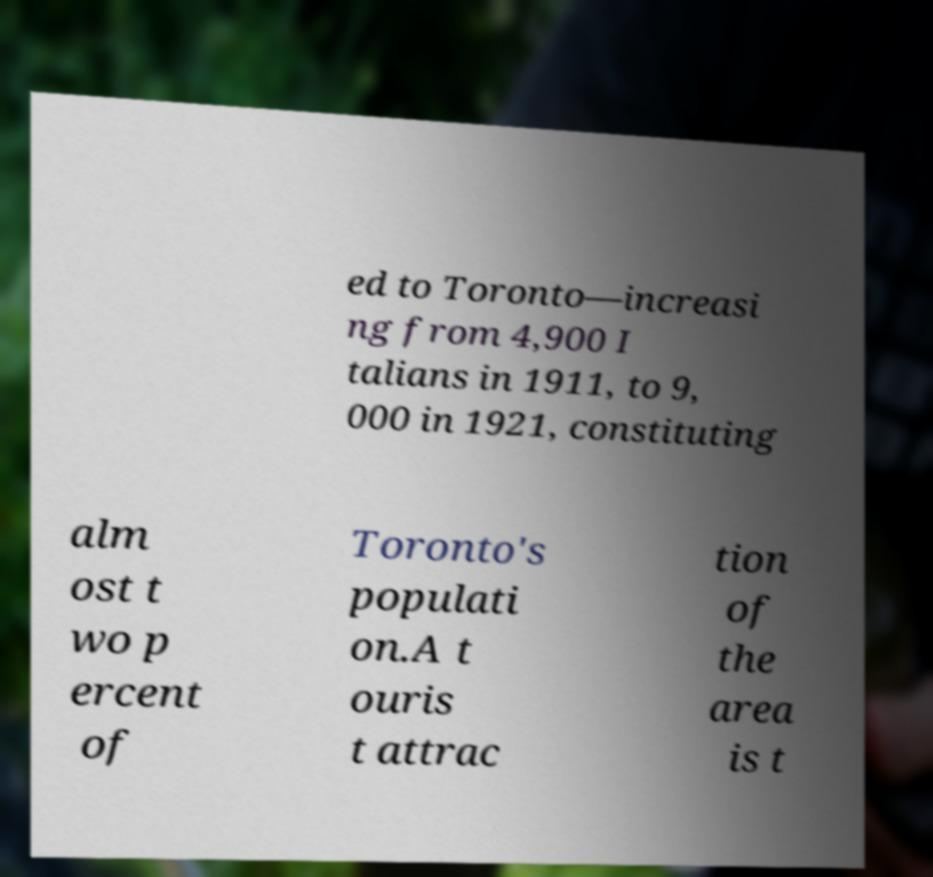I need the written content from this picture converted into text. Can you do that? ed to Toronto—increasi ng from 4,900 I talians in 1911, to 9, 000 in 1921, constituting alm ost t wo p ercent of Toronto's populati on.A t ouris t attrac tion of the area is t 